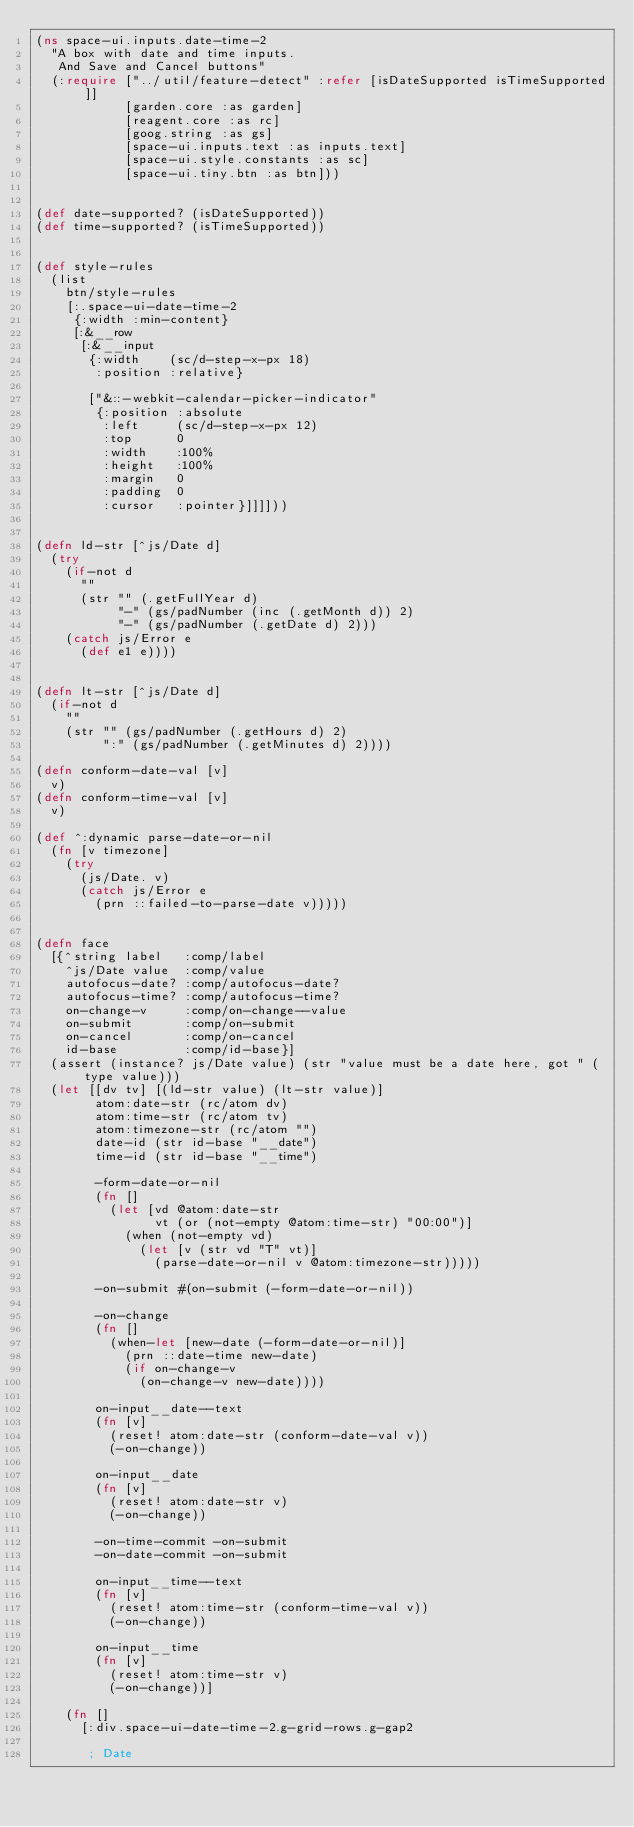Convert code to text. <code><loc_0><loc_0><loc_500><loc_500><_Clojure_>(ns space-ui.inputs.date-time-2
  "A box with date and time inputs.
   And Save and Cancel buttons"
  (:require ["../util/feature-detect" :refer [isDateSupported isTimeSupported]]
            [garden.core :as garden]
            [reagent.core :as rc]
            [goog.string :as gs]
            [space-ui.inputs.text :as inputs.text]
            [space-ui.style.constants :as sc]
            [space-ui.tiny.btn :as btn]))


(def date-supported? (isDateSupported))
(def time-supported? (isTimeSupported))


(def style-rules
  (list
    btn/style-rules
    [:.space-ui-date-time-2
     {:width :min-content}
     [:&__row
      [:&__input
       {:width    (sc/d-step-x-px 18)
        :position :relative}

       ["&::-webkit-calendar-picker-indicator"
        {:position :absolute
         :left     (sc/d-step-x-px 12)
         :top      0
         :width    :100%
         :height   :100%
         :margin   0
         :padding  0
         :cursor   :pointer}]]]]))


(defn ld-str [^js/Date d]
  (try
    (if-not d
      ""
      (str "" (.getFullYear d)
           "-" (gs/padNumber (inc (.getMonth d)) 2)
           "-" (gs/padNumber (.getDate d) 2)))
    (catch js/Error e
      (def e1 e))))


(defn lt-str [^js/Date d]
  (if-not d
    ""
    (str "" (gs/padNumber (.getHours d) 2)
         ":" (gs/padNumber (.getMinutes d) 2))))

(defn conform-date-val [v]
  v)
(defn conform-time-val [v]
  v)

(def ^:dynamic parse-date-or-nil
  (fn [v timezone]
    (try
      (js/Date. v)
      (catch js/Error e
        (prn ::failed-to-parse-date v)))))


(defn face
  [{^string label   :comp/label
    ^js/Date value  :comp/value
    autofocus-date? :comp/autofocus-date?
    autofocus-time? :comp/autofocus-time?
    on-change-v     :comp/on-change--value
    on-submit       :comp/on-submit
    on-cancel       :comp/on-cancel
    id-base         :comp/id-base}]
  (assert (instance? js/Date value) (str "value must be a date here, got " (type value)))
  (let [[dv tv] [(ld-str value) (lt-str value)]
        atom:date-str (rc/atom dv)
        atom:time-str (rc/atom tv)
        atom:timezone-str (rc/atom "")
        date-id (str id-base "__date")
        time-id (str id-base "__time")

        -form-date-or-nil
        (fn []
          (let [vd @atom:date-str
                vt (or (not-empty @atom:time-str) "00:00")]
            (when (not-empty vd)
              (let [v (str vd "T" vt)]
                (parse-date-or-nil v @atom:timezone-str)))))

        -on-submit #(on-submit (-form-date-or-nil))

        -on-change
        (fn []
          (when-let [new-date (-form-date-or-nil)]
            (prn ::date-time new-date)
            (if on-change-v
              (on-change-v new-date))))

        on-input__date--text
        (fn [v]
          (reset! atom:date-str (conform-date-val v))
          (-on-change))

        on-input__date
        (fn [v]
          (reset! atom:date-str v)
          (-on-change))

        -on-time-commit -on-submit
        -on-date-commit -on-submit

        on-input__time--text
        (fn [v]
          (reset! atom:time-str (conform-time-val v))
          (-on-change))

        on-input__time
        (fn [v]
          (reset! atom:time-str v)
          (-on-change))]

    (fn []
      [:div.space-ui-date-time-2.g-grid-rows.g-gap2

       ; Date</code> 